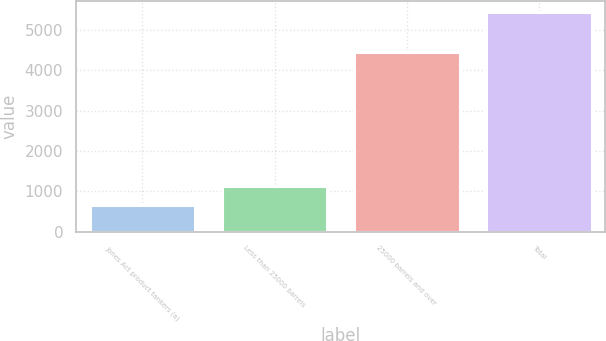<chart> <loc_0><loc_0><loc_500><loc_500><bar_chart><fcel>Jones Act product tankers (a)<fcel>Less than 25000 barrels<fcel>25000 barrels and over<fcel>Total<nl><fcel>660<fcel>1138.8<fcel>4453<fcel>5448<nl></chart> 